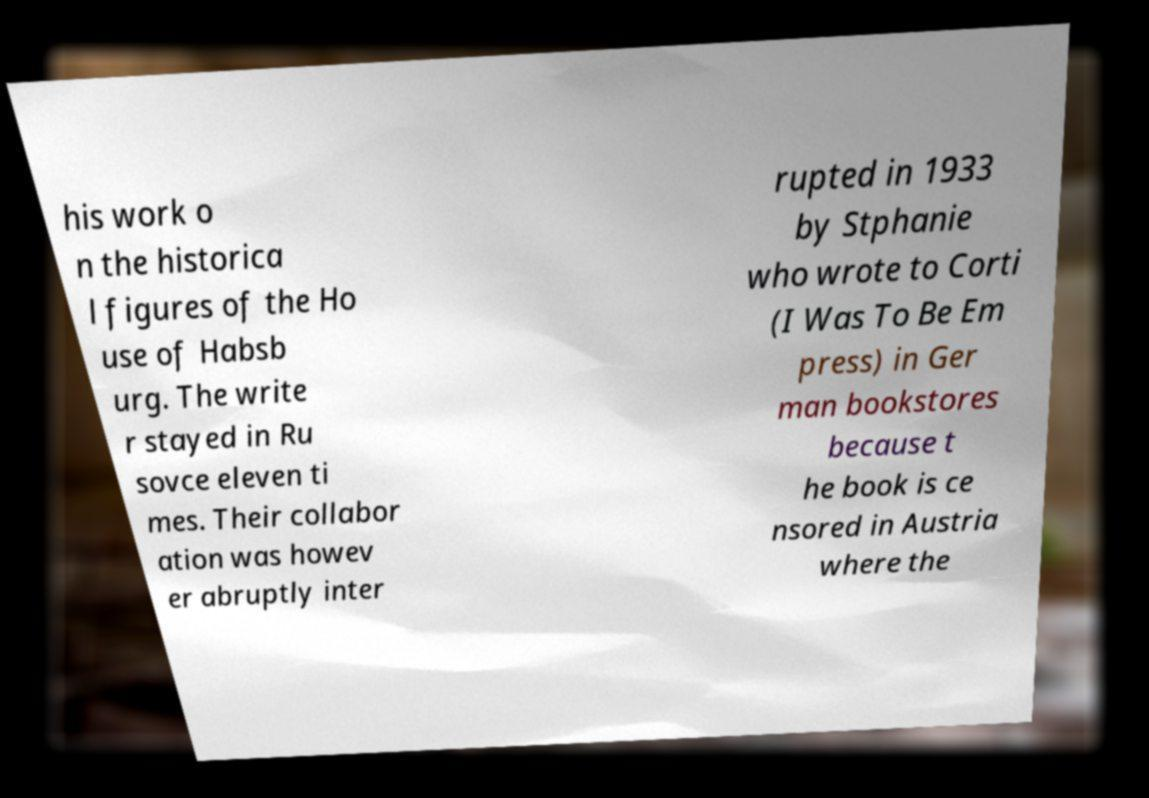Could you assist in decoding the text presented in this image and type it out clearly? his work o n the historica l figures of the Ho use of Habsb urg. The write r stayed in Ru sovce eleven ti mes. Their collabor ation was howev er abruptly inter rupted in 1933 by Stphanie who wrote to Corti (I Was To Be Em press) in Ger man bookstores because t he book is ce nsored in Austria where the 